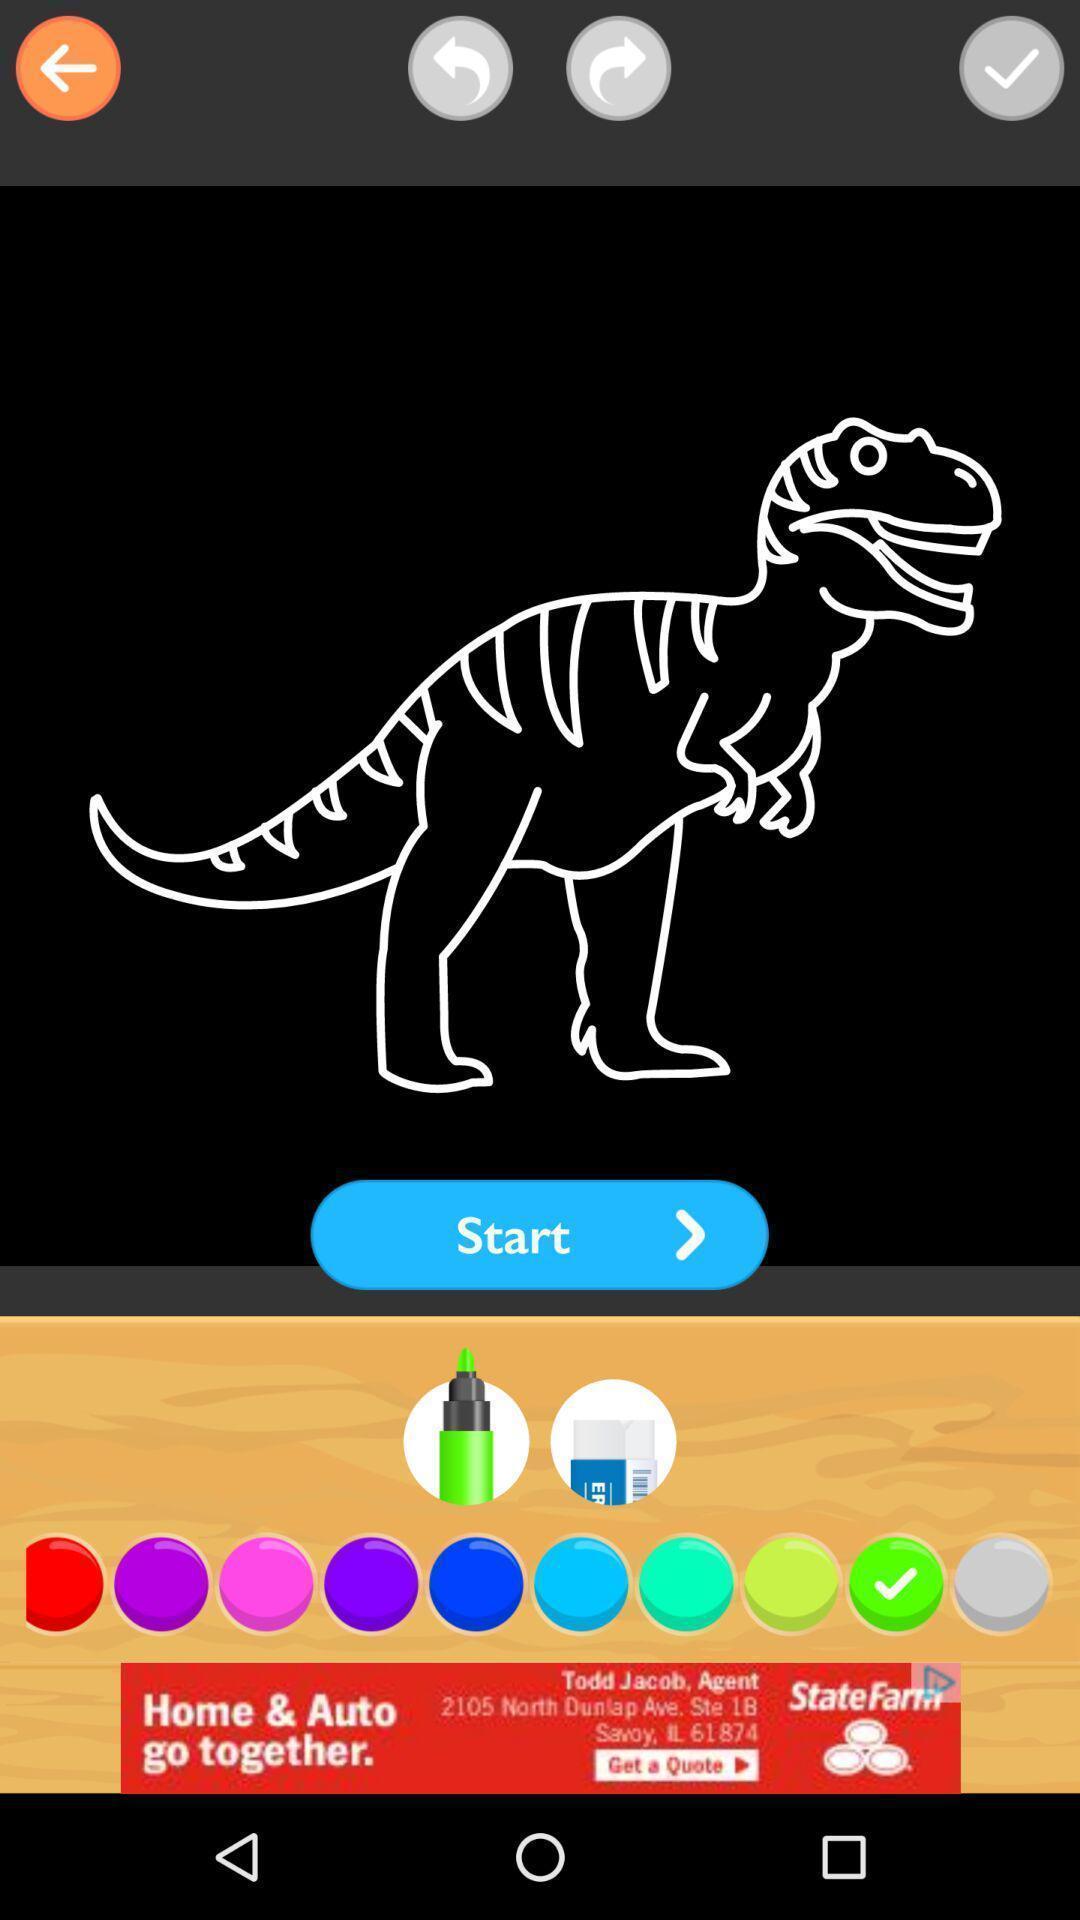Provide a textual representation of this image. Page showing the different colors to select. 